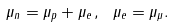Convert formula to latex. <formula><loc_0><loc_0><loc_500><loc_500>\mu _ { n } = \mu _ { p } + \mu _ { e } \, , \ \mu _ { e } = \mu _ { \mu } .</formula> 